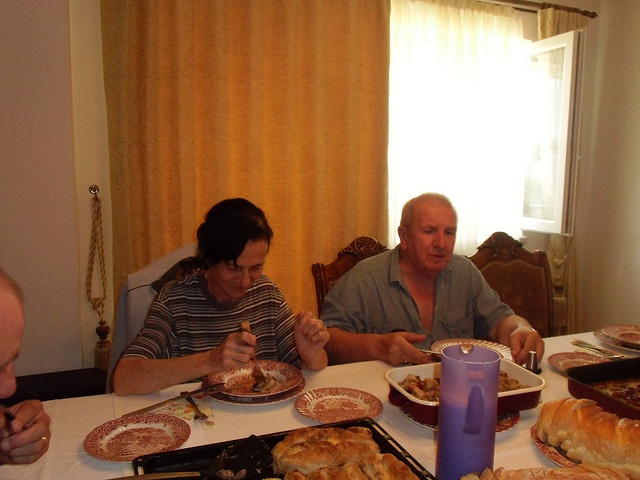Describe the objects in this image and their specific colors. I can see dining table in brown, maroon, black, and gray tones, people in brown, black, and maroon tones, people in brown, maroon, and black tones, cup in brown, purple, and maroon tones, and people in brown, maroon, and black tones in this image. 